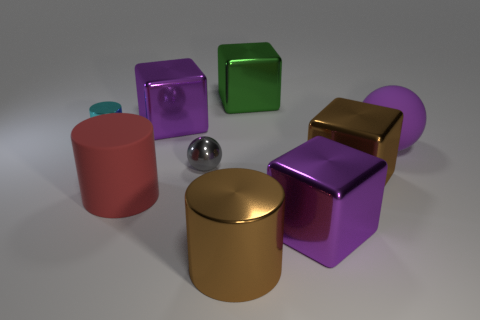Subtract all red blocks. Subtract all blue cylinders. How many blocks are left? 4 Add 1 small cylinders. How many objects exist? 10 Subtract all blocks. How many objects are left? 5 Add 3 large green things. How many large green things exist? 4 Subtract 1 cyan cylinders. How many objects are left? 8 Subtract all tiny red cylinders. Subtract all small objects. How many objects are left? 7 Add 8 large brown objects. How many large brown objects are left? 10 